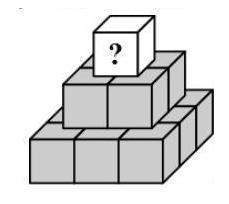Susi writes a different positive whole number on each of the 14 cubes of the pyramid (see diagram). The sum of the numbers, which she writes on the nine cubes that lie on the bottom, is 50. The number on every remaining cube is equal to the sum of the numbers of the four cubes that are directly underneath. What is the biggest number that can be written on the topmost cube? To ensure the topmost cube has the greatest possible number, we must position the lowest numbers at the pyramid's base, allowing for larger sums as we ascend the layers. So, starting with a sequential placement of the smallest whole numbers at the base, we find that the largest number possible at the top is indeed 118. This follows from careful addition of numbers according to the given pyramid structure, ensuring that the sum of any four cubes supports a single cube above. 